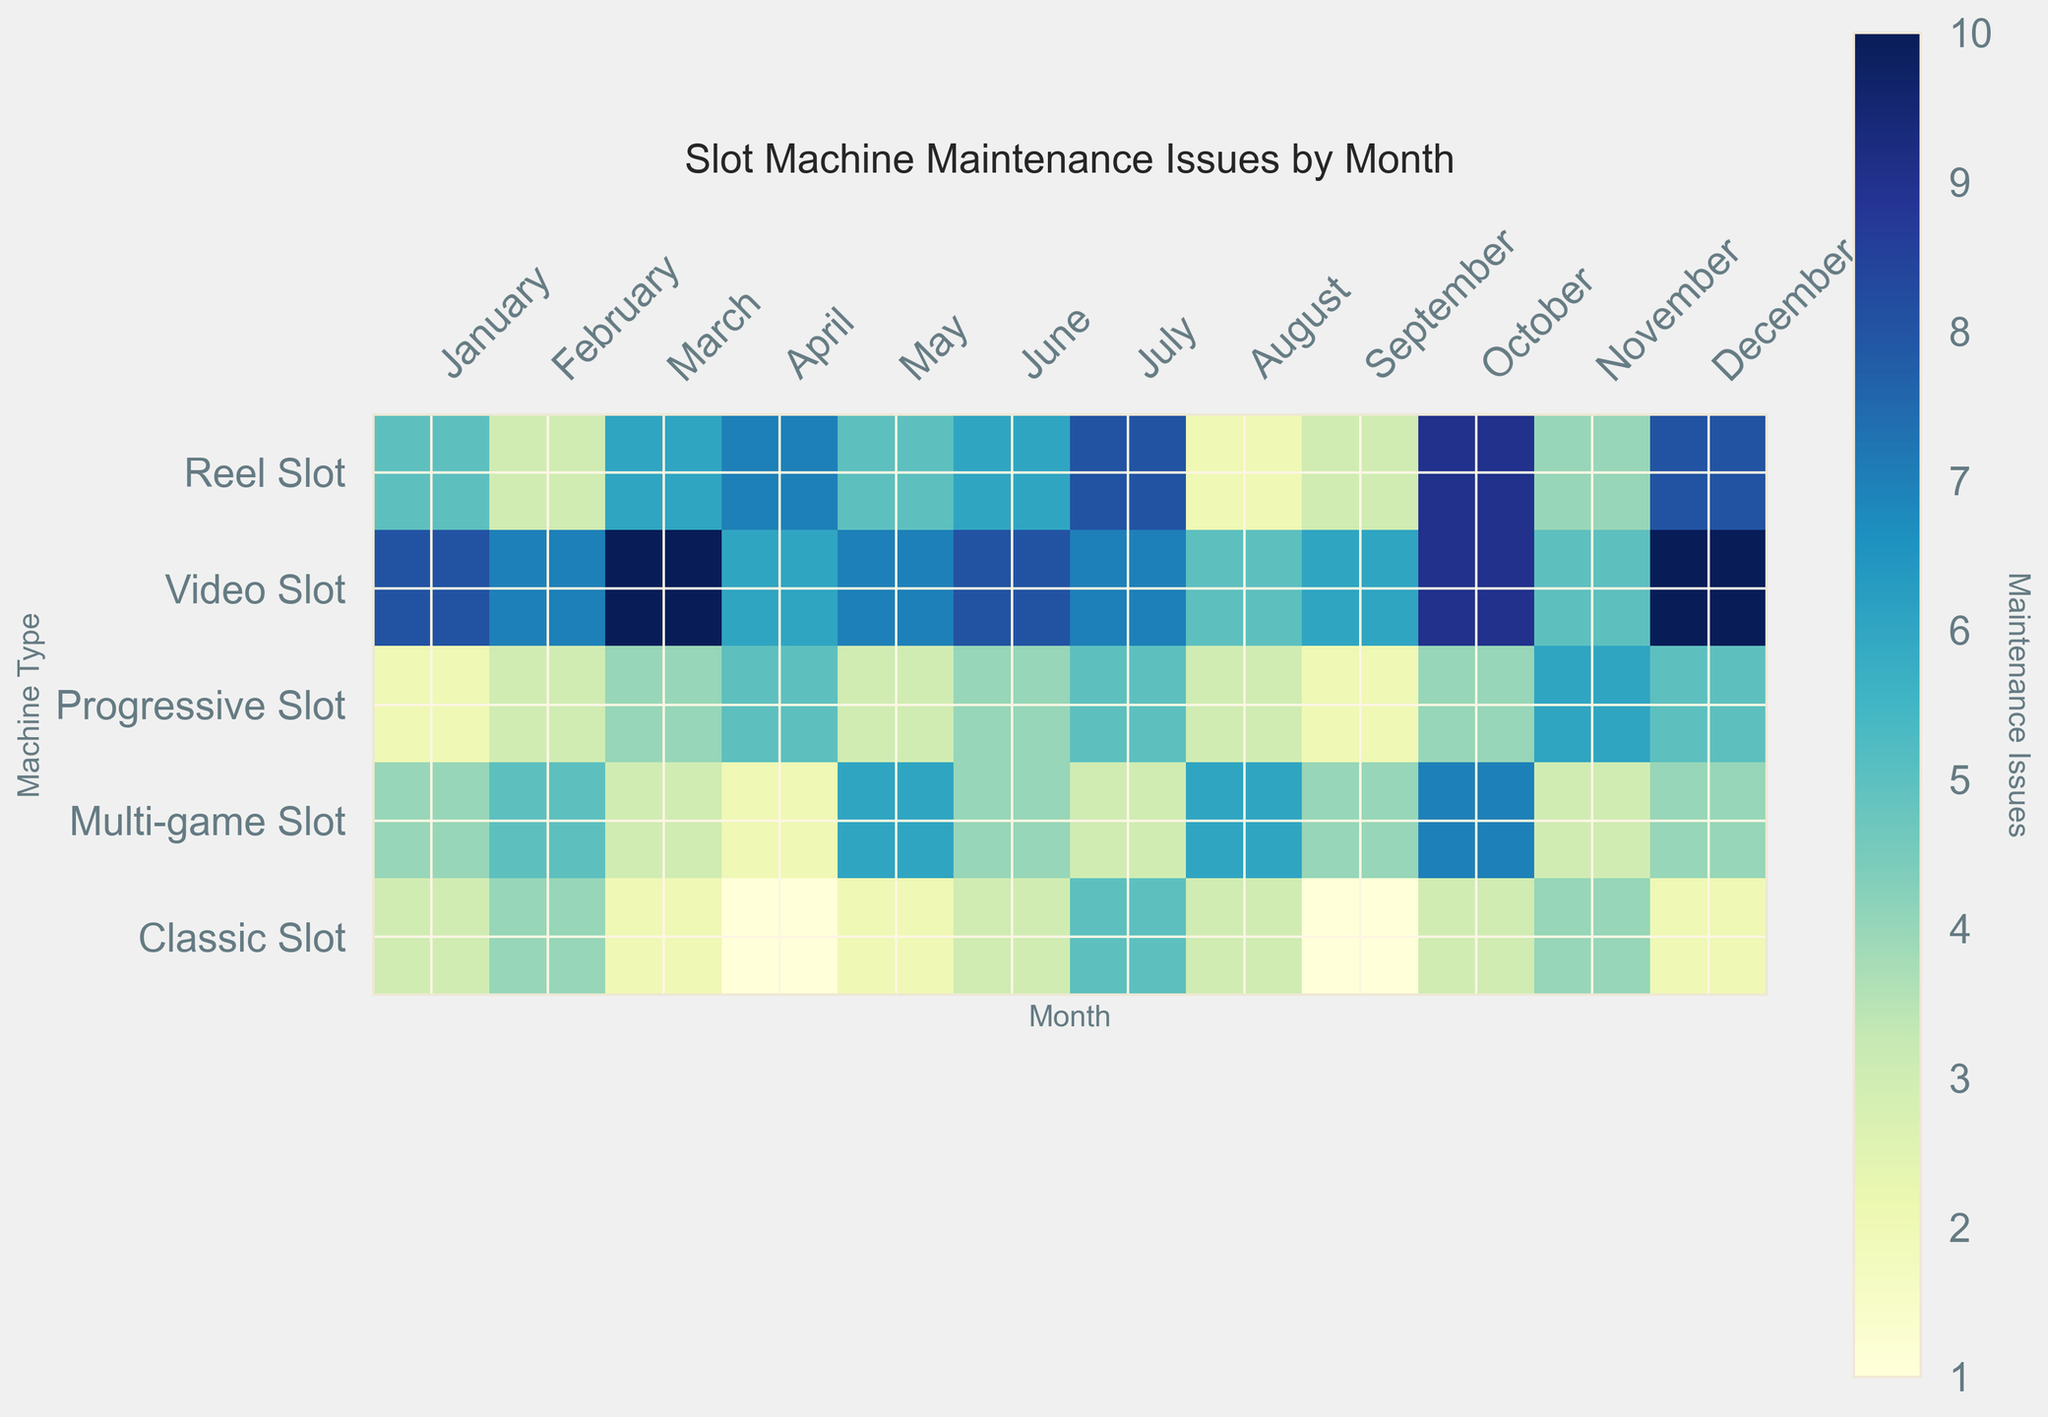Which machine type had the most maintenance issues in June? To figure this out, locate June on the x-axis and see which machine type has the highest number in that column. For June, the highest number is 8, which corresponds to the Video Slot.
Answer: Video Slot How many total maintenance issues did the Classic Slot machines have in the second quarter (April, May, June)? Sum the values for Classic Slot in April, May, and June: 1 (April) + 2 (May) + 3 (June). 1 + 2 + 3 equals 6.
Answer: 6 What is the difference in maintenance issues between Reel Slot and Progressive Slot machines in October? Find the values for both Reel Slot and Progressive Slot in October and subtract them: 9 (Reel Slot) - 4 (Progressive Slot). The difference is 5.
Answer: 5 Which month had the highest total maintenance issues across all machine types? For each month, add up the maintenance issues across all machine types. Verify the totals for all months. October has the highest total with 9 + 9 + 4 + 7 + 3 = 32.
Answer: October Is there any month where the Multi-game Slot had more maintenance issues than the Reel Slot? Compare the values for Multi-game Slot and Reel Slot month by month to see if there is any month where the former is greater. Only in April does the Multi-game Slot (2) exceed the Reel Slot (7).
Answer: No In which month did Progressive Slot machines have their lowest maintenance issues? Look at the data for Progressive Slot month by month to find the lowest number. The lowest value is 2, which appears in January and September.
Answer: January and September Was there a month when all machine types had fewer than 10 maintenance issues each? Check each month’s values to ensure all values are below 10. For instance, April has values 7, 6, 5, 2, and 1 all under 10.
Answer: Yes, April What is the average number of maintenance issues for Video Slot machines from January to December? Add up all maintenance issues for the Video Slot and divide by 12: (8 + 7 + 10 + 6 + 7 + 8 + 7 + 5 + 6 + 9 + 5 + 10) / 12. The total is 88, so the average is 88 / 12 = 7.33.
Answer: 7.33 Which machine type had the least maintenance issues in November? Look at the values for each machine type in November and find the smallest number. The smallest number is 3, which corresponds to Multi-game Slot.
Answer: Multi-game Slot How many maintenance issues were there for Reel Slot machines in the first half of the year (January to June)? Add up the Reel Slot values from January to June: 5 + 3 + 6 + 7 + 5 + 6. 5 + 3 + 6 + 7 + 5 + 6 = 32.
Answer: 32 